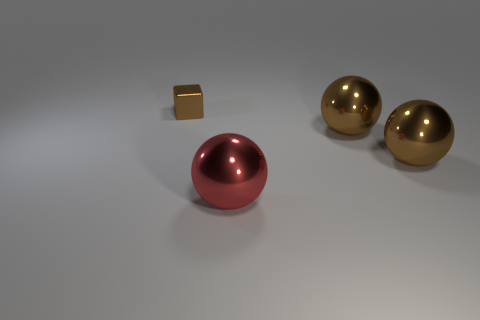Add 4 tiny brown metal things. How many objects exist? 8 Subtract all cubes. How many objects are left? 3 Add 1 small brown metallic objects. How many small brown metallic objects exist? 2 Subtract 0 green cylinders. How many objects are left? 4 Subtract all tiny red shiny blocks. Subtract all red metallic balls. How many objects are left? 3 Add 4 large red metallic balls. How many large red metallic balls are left? 5 